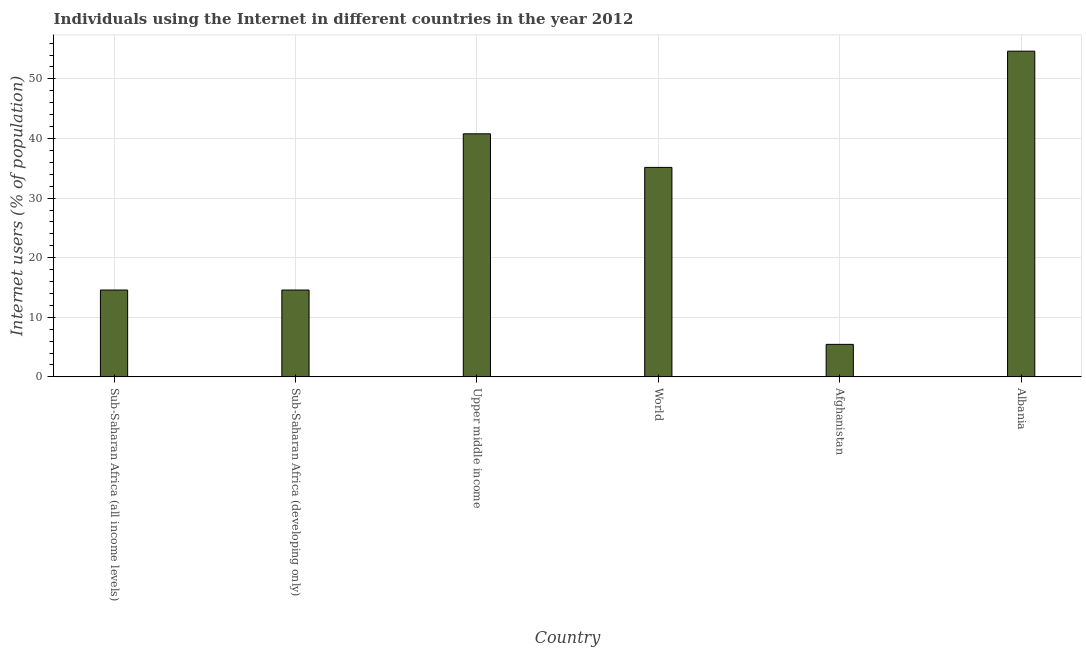Does the graph contain grids?
Ensure brevity in your answer.  Yes. What is the title of the graph?
Ensure brevity in your answer.  Individuals using the Internet in different countries in the year 2012. What is the label or title of the Y-axis?
Provide a succinct answer. Internet users (% of population). What is the number of internet users in Sub-Saharan Africa (developing only)?
Provide a short and direct response. 14.57. Across all countries, what is the maximum number of internet users?
Offer a terse response. 54.66. Across all countries, what is the minimum number of internet users?
Make the answer very short. 5.45. In which country was the number of internet users maximum?
Your response must be concise. Albania. In which country was the number of internet users minimum?
Provide a succinct answer. Afghanistan. What is the sum of the number of internet users?
Give a very brief answer. 165.19. What is the difference between the number of internet users in Albania and Sub-Saharan Africa (developing only)?
Give a very brief answer. 40.09. What is the average number of internet users per country?
Your response must be concise. 27.53. What is the median number of internet users?
Give a very brief answer. 24.86. In how many countries, is the number of internet users greater than 8 %?
Your answer should be very brief. 5. What is the ratio of the number of internet users in Sub-Saharan Africa (developing only) to that in Upper middle income?
Provide a succinct answer. 0.36. Is the number of internet users in Upper middle income less than that in World?
Provide a short and direct response. No. Is the difference between the number of internet users in Sub-Saharan Africa (developing only) and World greater than the difference between any two countries?
Give a very brief answer. No. What is the difference between the highest and the second highest number of internet users?
Give a very brief answer. 13.87. Is the sum of the number of internet users in Albania and Upper middle income greater than the maximum number of internet users across all countries?
Your response must be concise. Yes. What is the difference between the highest and the lowest number of internet users?
Provide a succinct answer. 49.2. How many bars are there?
Your answer should be compact. 6. Are all the bars in the graph horizontal?
Your response must be concise. No. What is the Internet users (% of population) of Sub-Saharan Africa (all income levels)?
Your answer should be very brief. 14.57. What is the Internet users (% of population) of Sub-Saharan Africa (developing only)?
Your response must be concise. 14.57. What is the Internet users (% of population) in Upper middle income?
Your answer should be very brief. 40.79. What is the Internet users (% of population) in World?
Give a very brief answer. 35.15. What is the Internet users (% of population) of Afghanistan?
Your answer should be compact. 5.45. What is the Internet users (% of population) of Albania?
Make the answer very short. 54.66. What is the difference between the Internet users (% of population) in Sub-Saharan Africa (all income levels) and Sub-Saharan Africa (developing only)?
Provide a short and direct response. 0. What is the difference between the Internet users (% of population) in Sub-Saharan Africa (all income levels) and Upper middle income?
Ensure brevity in your answer.  -26.21. What is the difference between the Internet users (% of population) in Sub-Saharan Africa (all income levels) and World?
Your response must be concise. -20.58. What is the difference between the Internet users (% of population) in Sub-Saharan Africa (all income levels) and Afghanistan?
Make the answer very short. 9.12. What is the difference between the Internet users (% of population) in Sub-Saharan Africa (all income levels) and Albania?
Your response must be concise. -40.08. What is the difference between the Internet users (% of population) in Sub-Saharan Africa (developing only) and Upper middle income?
Your answer should be compact. -26.22. What is the difference between the Internet users (% of population) in Sub-Saharan Africa (developing only) and World?
Keep it short and to the point. -20.58. What is the difference between the Internet users (% of population) in Sub-Saharan Africa (developing only) and Afghanistan?
Offer a terse response. 9.12. What is the difference between the Internet users (% of population) in Sub-Saharan Africa (developing only) and Albania?
Your answer should be compact. -40.09. What is the difference between the Internet users (% of population) in Upper middle income and World?
Your response must be concise. 5.64. What is the difference between the Internet users (% of population) in Upper middle income and Afghanistan?
Offer a terse response. 35.33. What is the difference between the Internet users (% of population) in Upper middle income and Albania?
Your answer should be compact. -13.87. What is the difference between the Internet users (% of population) in World and Afghanistan?
Your response must be concise. 29.69. What is the difference between the Internet users (% of population) in World and Albania?
Your answer should be compact. -19.51. What is the difference between the Internet users (% of population) in Afghanistan and Albania?
Give a very brief answer. -49.2. What is the ratio of the Internet users (% of population) in Sub-Saharan Africa (all income levels) to that in Sub-Saharan Africa (developing only)?
Your answer should be very brief. 1. What is the ratio of the Internet users (% of population) in Sub-Saharan Africa (all income levels) to that in Upper middle income?
Your answer should be very brief. 0.36. What is the ratio of the Internet users (% of population) in Sub-Saharan Africa (all income levels) to that in World?
Provide a succinct answer. 0.41. What is the ratio of the Internet users (% of population) in Sub-Saharan Africa (all income levels) to that in Afghanistan?
Your answer should be very brief. 2.67. What is the ratio of the Internet users (% of population) in Sub-Saharan Africa (all income levels) to that in Albania?
Make the answer very short. 0.27. What is the ratio of the Internet users (% of population) in Sub-Saharan Africa (developing only) to that in Upper middle income?
Ensure brevity in your answer.  0.36. What is the ratio of the Internet users (% of population) in Sub-Saharan Africa (developing only) to that in World?
Make the answer very short. 0.41. What is the ratio of the Internet users (% of population) in Sub-Saharan Africa (developing only) to that in Afghanistan?
Offer a very short reply. 2.67. What is the ratio of the Internet users (% of population) in Sub-Saharan Africa (developing only) to that in Albania?
Offer a very short reply. 0.27. What is the ratio of the Internet users (% of population) in Upper middle income to that in World?
Offer a very short reply. 1.16. What is the ratio of the Internet users (% of population) in Upper middle income to that in Afghanistan?
Your answer should be compact. 7.48. What is the ratio of the Internet users (% of population) in Upper middle income to that in Albania?
Offer a very short reply. 0.75. What is the ratio of the Internet users (% of population) in World to that in Afghanistan?
Your response must be concise. 6.44. What is the ratio of the Internet users (% of population) in World to that in Albania?
Provide a short and direct response. 0.64. What is the ratio of the Internet users (% of population) in Afghanistan to that in Albania?
Your response must be concise. 0.1. 